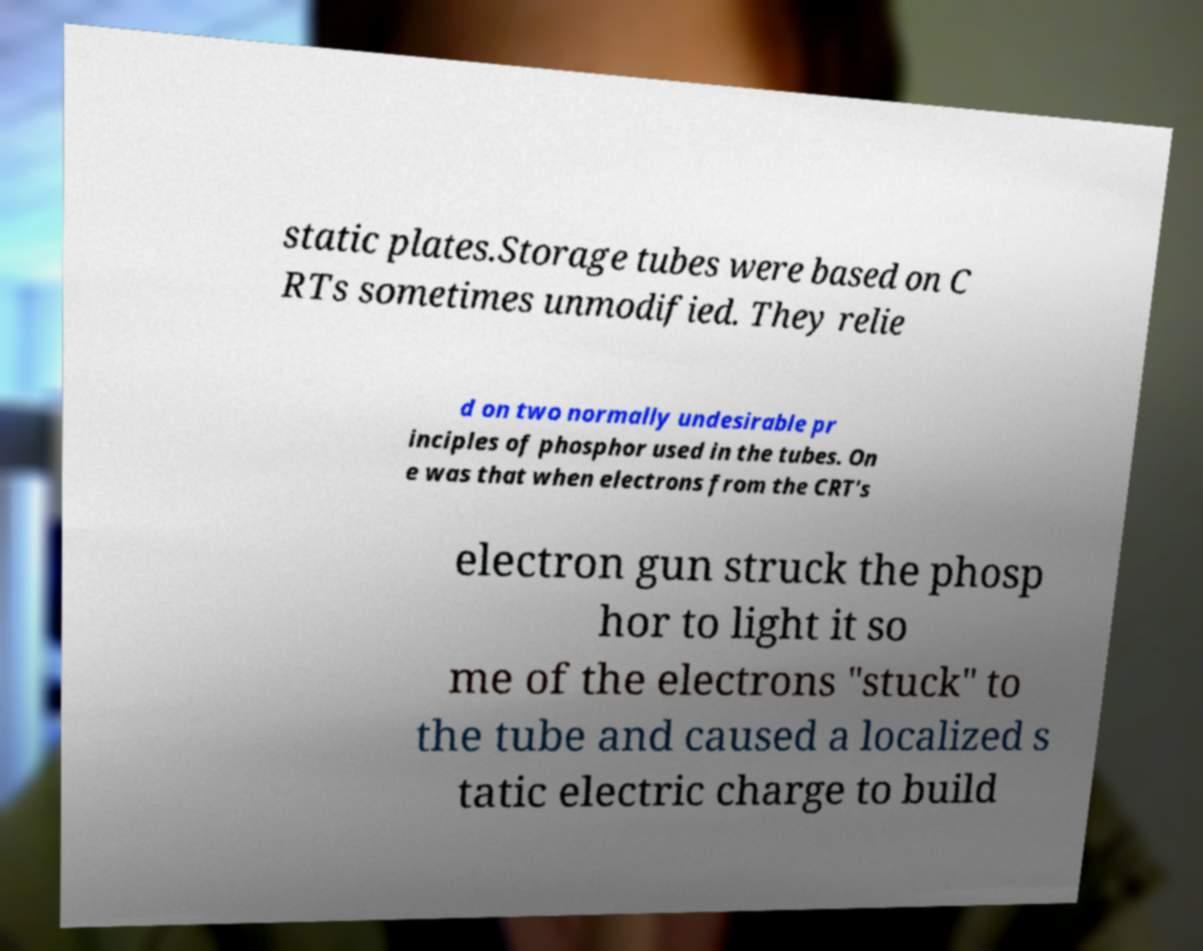There's text embedded in this image that I need extracted. Can you transcribe it verbatim? static plates.Storage tubes were based on C RTs sometimes unmodified. They relie d on two normally undesirable pr inciples of phosphor used in the tubes. On e was that when electrons from the CRT's electron gun struck the phosp hor to light it so me of the electrons "stuck" to the tube and caused a localized s tatic electric charge to build 